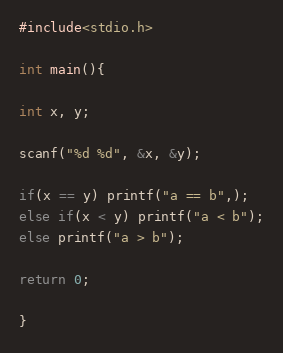<code> <loc_0><loc_0><loc_500><loc_500><_C_>#include<stdio.h>

int main(){

int x, y;

scanf("%d %d", &x, &y);

if(x == y) printf("a == b",);
else if(x < y) printf("a < b");
else printf("a > b");

return 0;

}</code> 